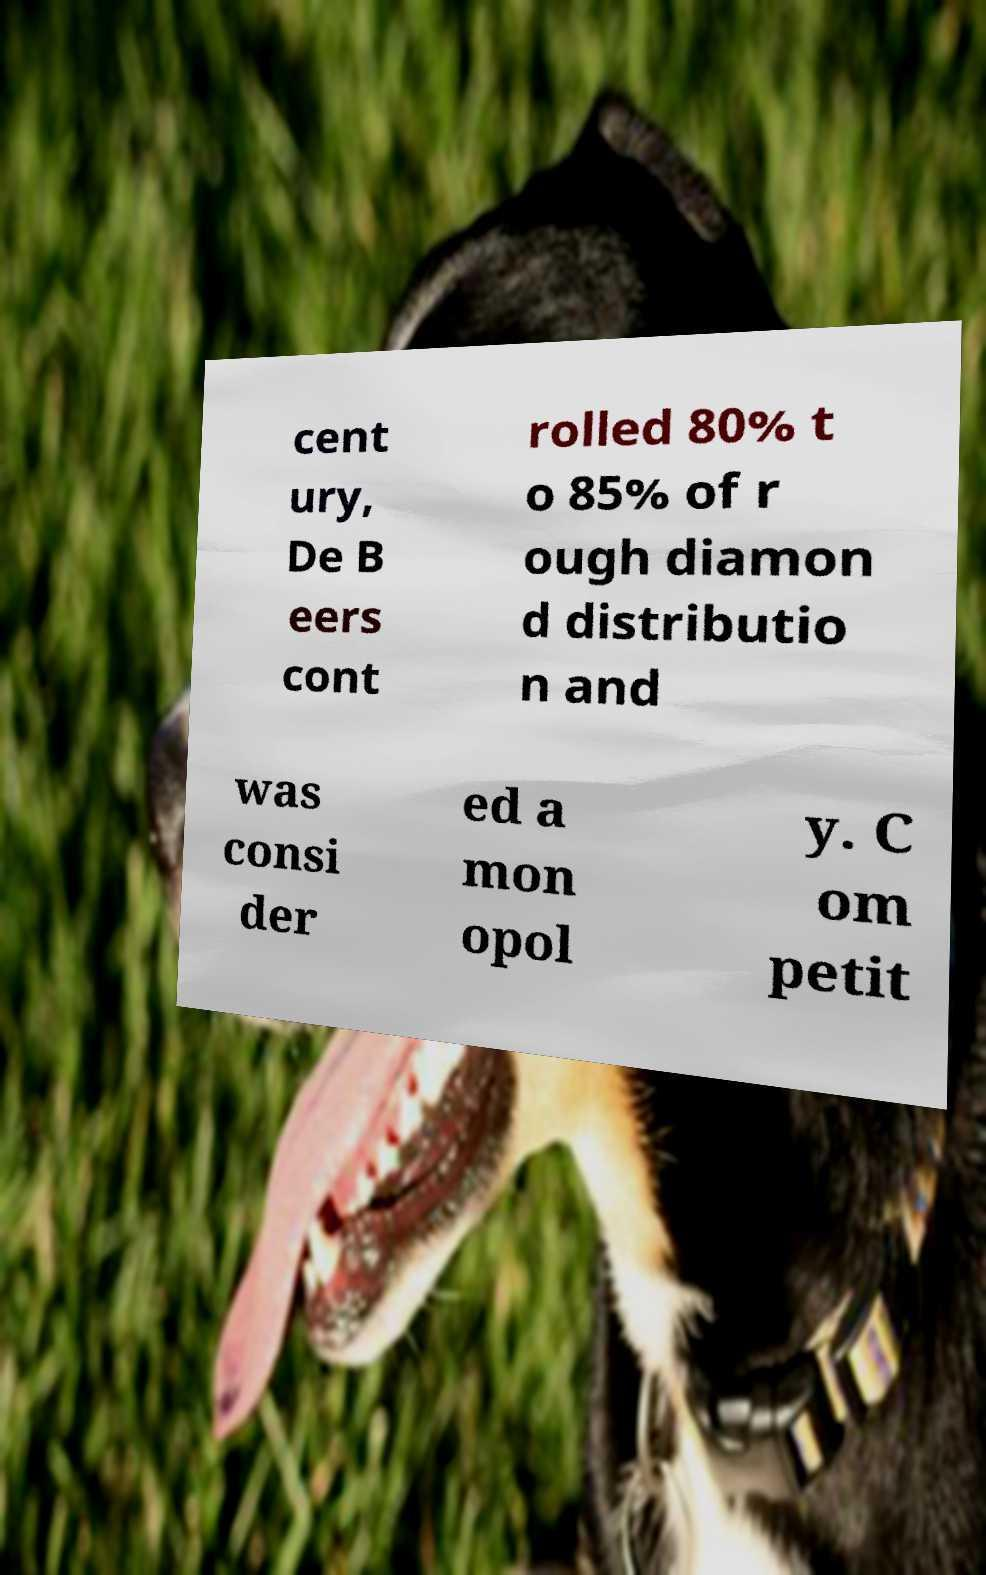I need the written content from this picture converted into text. Can you do that? cent ury, De B eers cont rolled 80% t o 85% of r ough diamon d distributio n and was consi der ed a mon opol y. C om petit 